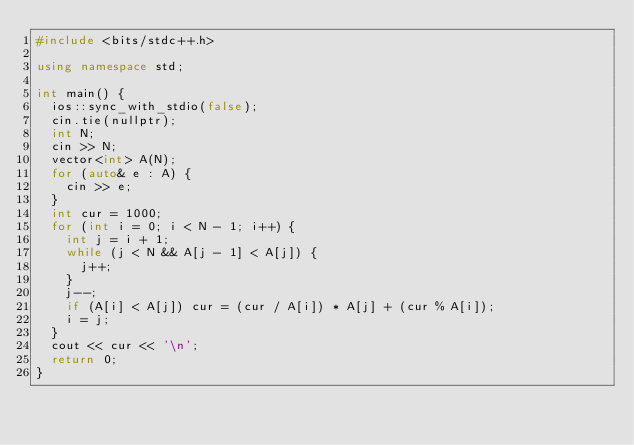<code> <loc_0><loc_0><loc_500><loc_500><_C++_>#include <bits/stdc++.h>

using namespace std;

int main() {
  ios::sync_with_stdio(false);
  cin.tie(nullptr);
  int N;
  cin >> N;
  vector<int> A(N);
  for (auto& e : A) {
    cin >> e;
  }
  int cur = 1000;
  for (int i = 0; i < N - 1; i++) {
    int j = i + 1;
    while (j < N && A[j - 1] < A[j]) {
      j++;
    }
    j--;
    if (A[i] < A[j]) cur = (cur / A[i]) * A[j] + (cur % A[i]);
    i = j;
  }
  cout << cur << '\n';
  return 0;
}
</code> 